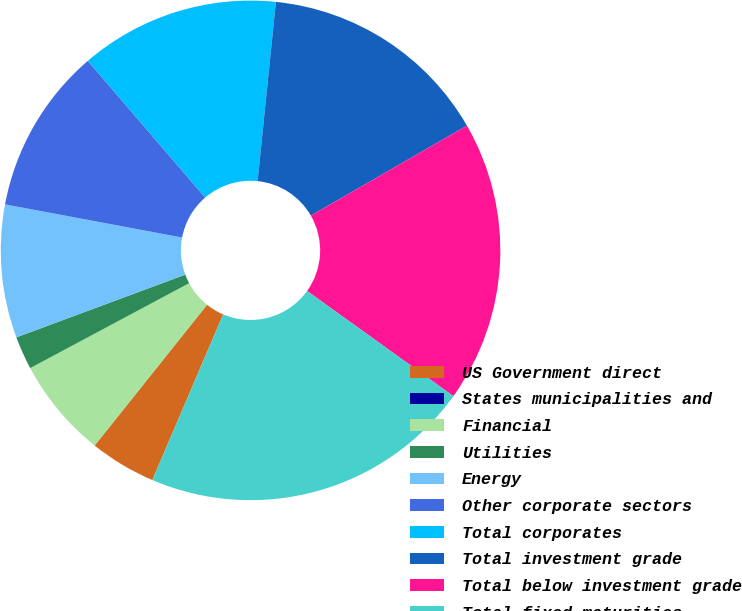Convert chart. <chart><loc_0><loc_0><loc_500><loc_500><pie_chart><fcel>US Government direct<fcel>States municipalities and<fcel>Financial<fcel>Utilities<fcel>Energy<fcel>Other corporate sectors<fcel>Total corporates<fcel>Total investment grade<fcel>Total below investment grade<fcel>Total fixed maturities<nl><fcel>4.3%<fcel>0.0%<fcel>6.46%<fcel>2.15%<fcel>8.61%<fcel>10.76%<fcel>12.91%<fcel>15.06%<fcel>18.24%<fcel>21.51%<nl></chart> 